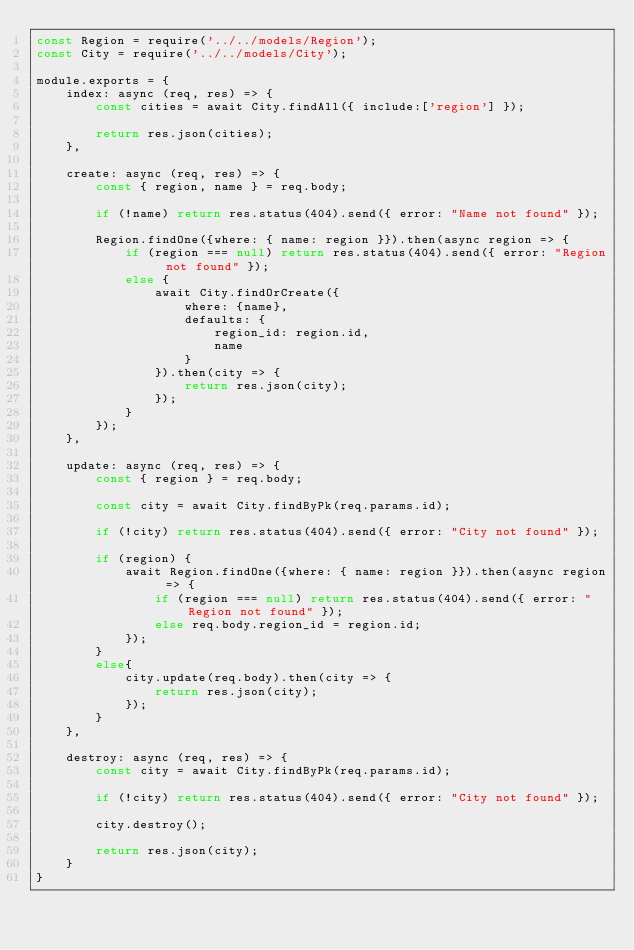Convert code to text. <code><loc_0><loc_0><loc_500><loc_500><_JavaScript_>const Region = require('../../models/Region');
const City = require('../../models/City');

module.exports = {
    index: async (req, res) => {
        const cities = await City.findAll({ include:['region'] });

        return res.json(cities);
    },
    
    create: async (req, res) => { 
        const { region, name } = req.body;

        if (!name) return res.status(404).send({ error: "Name not found" });

        Region.findOne({where: { name: region }}).then(async region => {
            if (region === null) return res.status(404).send({ error: "Region not found" });
            else {
                await City.findOrCreate({
                    where: {name},
                    defaults: {
                        region_id: region.id,
                        name
                    }
                }).then(city => {
                    return res.json(city);
                });
            }
        });
    },
    
    update: async (req, res) => {
        const { region } = req.body;

        const city = await City.findByPk(req.params.id);

        if (!city) return res.status(404).send({ error: "City not found" });

        if (region) {
            await Region.findOne({where: { name: region }}).then(async region => {
                if (region === null) return res.status(404).send({ error: "Region not found" });
                else req.body.region_id = region.id;
            });
        }
        else{
            city.update(req.body).then(city => {
                return res.json(city);
            }); 
        }  
    },

    destroy: async (req, res) => {
        const city = await City.findByPk(req.params.id);

        if (!city) return res.status(404).send({ error: "City not found" });

        city.destroy();

        return res.json(city);
    }
}</code> 